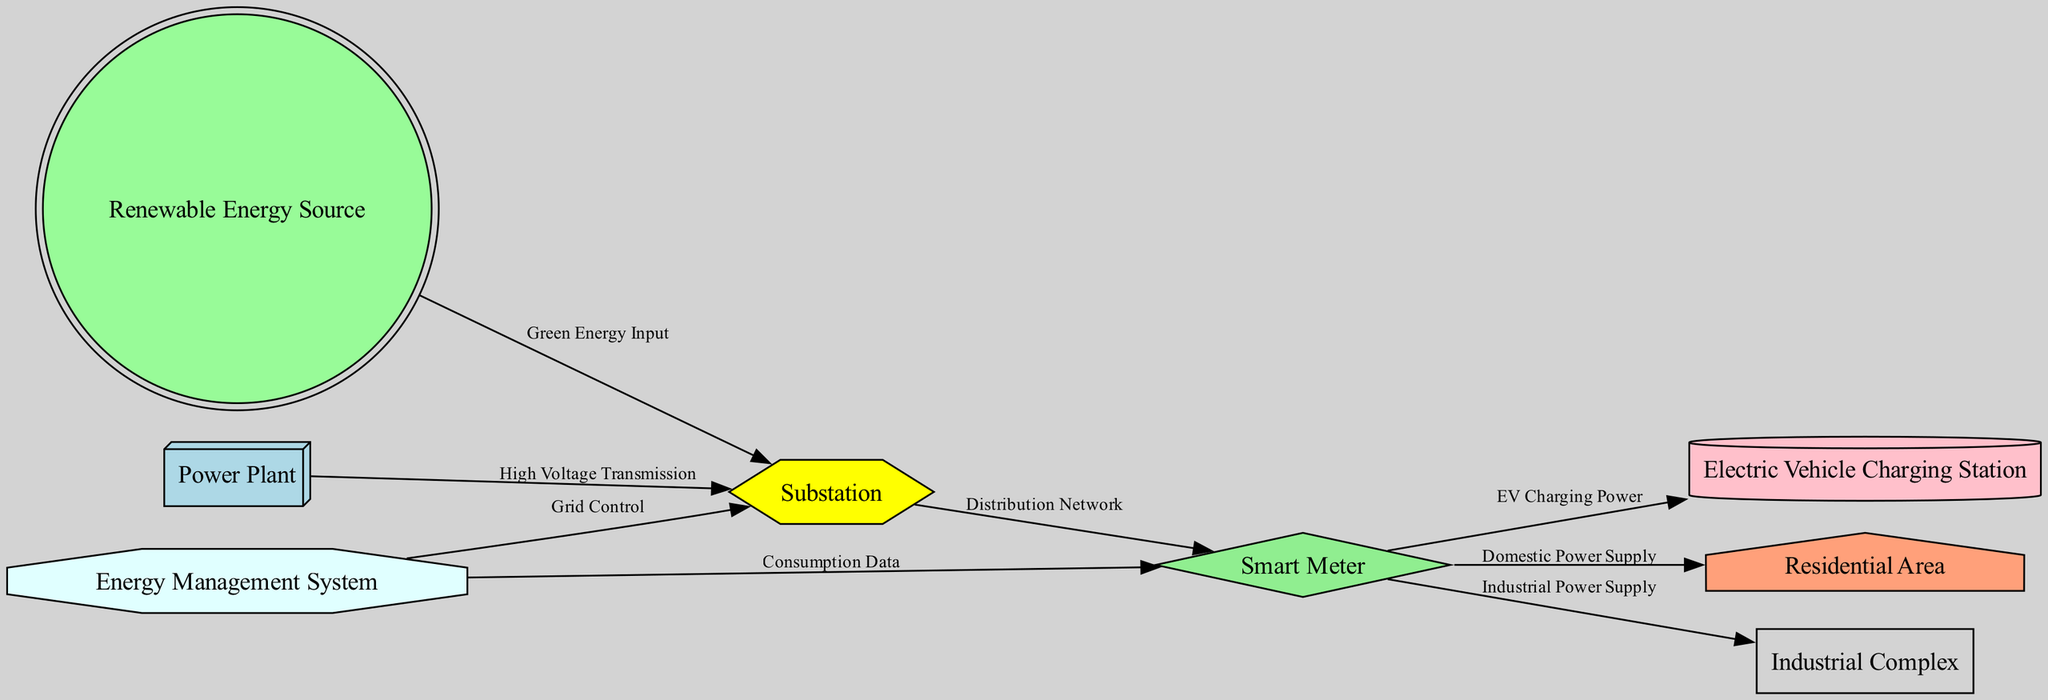What is the starting point of high voltage transmission? The starting point of high voltage transmission is the "Power Plant," which is represented as the first node in the diagram, indicating that power is generated here and then transmitted to the substation.
Answer: Power Plant How many nodes are present in the diagram? The diagram contains a total of eight nodes, each representing a distinct component or area in the smart grid system. These nodes are: Power Plant, Substation, Smart Meter, Electric Vehicle Charging Station, Residential Area, Industrial Complex, Renewable Energy Source, and Energy Management System.
Answer: Eight What type of connection exists between the Substation and the Smart Meter? The connection between the Substation and the Smart Meter is labeled "Distribution Network," reflecting the role of the substation in distributing the electrical power received from the power plant to the smart meter.
Answer: Distribution Network Which node receives green energy input? The node that receives green energy input is the "Substation," as indicated by the edge labeled "Green Energy Input" that connects the Renewable Energy Source to the Substation.
Answer: Substation What does the Energy Management System provide to the Smart Meter? The Energy Management System provides "Consumption Data" to the Smart Meter, as indicated by the directed edge connecting these two nodes in the diagram.
Answer: Consumption Data How does power reach the Electric Vehicle Charging Station? Power reaches the Electric Vehicle Charging Station through the Smart Meter, as indicated by the edge labeled "EV Charging Power," which shows the flow of power from the Smart Meter to the Charging Station.
Answer: Smart Meter Which components are directly connected to the Smart Meter? The components that are directly connected to the Smart Meter include the Residential Area, Industrial Complex, and Electric Vehicle Charging Station, as shown by the three edges originating from the Smart Meter towards these nodes.
Answer: Residential Area, Industrial Complex, Electric Vehicle Charging Station What type of relationship is shown between the Renewable Energy Source and the Substation? The relationship between the Renewable Energy Source and the Substation is shown as a "Green Energy Input," indicating that renewable energy contributes to the power supplied to the substation.
Answer: Green Energy Input 